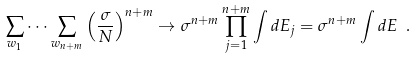Convert formula to latex. <formula><loc_0><loc_0><loc_500><loc_500>\sum _ { w _ { 1 } } \dots \sum _ { w _ { n + m } } \left ( \frac { \sigma } { N } \right ) ^ { n + m } \rightarrow \sigma ^ { n + m } \prod _ { j = 1 } ^ { n + m } \int d E _ { j } = \sigma ^ { n + m } \int d E \ .</formula> 